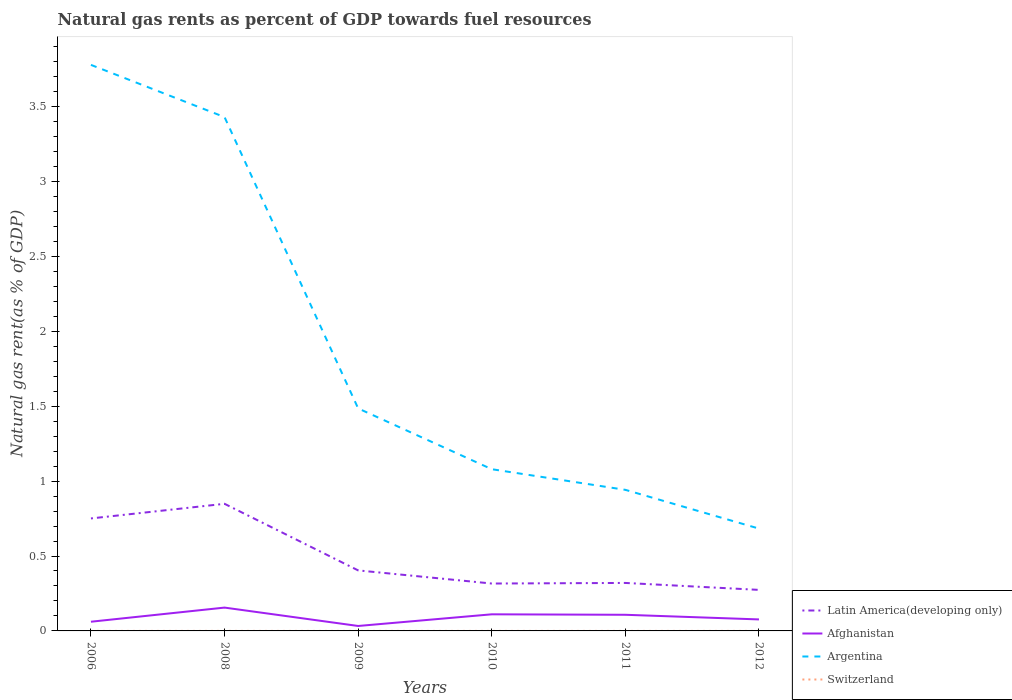Is the number of lines equal to the number of legend labels?
Keep it short and to the point. Yes. Across all years, what is the maximum natural gas rent in Afghanistan?
Provide a succinct answer. 0.03. What is the total natural gas rent in Switzerland in the graph?
Provide a succinct answer. 4.713673682386699e-5. What is the difference between the highest and the second highest natural gas rent in Argentina?
Your answer should be very brief. 3.09. What is the difference between the highest and the lowest natural gas rent in Latin America(developing only)?
Provide a short and direct response. 2. How many lines are there?
Offer a very short reply. 4. How many years are there in the graph?
Your answer should be compact. 6. Where does the legend appear in the graph?
Your response must be concise. Bottom right. What is the title of the graph?
Your answer should be very brief. Natural gas rents as percent of GDP towards fuel resources. Does "Belize" appear as one of the legend labels in the graph?
Provide a short and direct response. No. What is the label or title of the X-axis?
Your response must be concise. Years. What is the label or title of the Y-axis?
Keep it short and to the point. Natural gas rent(as % of GDP). What is the Natural gas rent(as % of GDP) in Latin America(developing only) in 2006?
Offer a terse response. 0.75. What is the Natural gas rent(as % of GDP) of Afghanistan in 2006?
Ensure brevity in your answer.  0.06. What is the Natural gas rent(as % of GDP) in Argentina in 2006?
Give a very brief answer. 3.78. What is the Natural gas rent(as % of GDP) of Switzerland in 2006?
Keep it short and to the point. 4.940501122730999e-5. What is the Natural gas rent(as % of GDP) in Latin America(developing only) in 2008?
Your answer should be compact. 0.85. What is the Natural gas rent(as % of GDP) of Afghanistan in 2008?
Keep it short and to the point. 0.16. What is the Natural gas rent(as % of GDP) of Argentina in 2008?
Your response must be concise. 3.43. What is the Natural gas rent(as % of GDP) in Switzerland in 2008?
Offer a very short reply. 0. What is the Natural gas rent(as % of GDP) of Latin America(developing only) in 2009?
Give a very brief answer. 0.4. What is the Natural gas rent(as % of GDP) of Afghanistan in 2009?
Keep it short and to the point. 0.03. What is the Natural gas rent(as % of GDP) of Argentina in 2009?
Make the answer very short. 1.48. What is the Natural gas rent(as % of GDP) in Switzerland in 2009?
Provide a short and direct response. 9.64984358457631e-5. What is the Natural gas rent(as % of GDP) in Latin America(developing only) in 2010?
Offer a terse response. 0.32. What is the Natural gas rent(as % of GDP) of Afghanistan in 2010?
Your answer should be compact. 0.11. What is the Natural gas rent(as % of GDP) in Argentina in 2010?
Give a very brief answer. 1.08. What is the Natural gas rent(as % of GDP) of Switzerland in 2010?
Provide a short and direct response. 0. What is the Natural gas rent(as % of GDP) of Latin America(developing only) in 2011?
Your answer should be very brief. 0.32. What is the Natural gas rent(as % of GDP) of Afghanistan in 2011?
Offer a very short reply. 0.11. What is the Natural gas rent(as % of GDP) in Argentina in 2011?
Provide a short and direct response. 0.94. What is the Natural gas rent(as % of GDP) of Switzerland in 2011?
Your answer should be very brief. 0. What is the Natural gas rent(as % of GDP) in Latin America(developing only) in 2012?
Give a very brief answer. 0.27. What is the Natural gas rent(as % of GDP) of Afghanistan in 2012?
Your answer should be very brief. 0.08. What is the Natural gas rent(as % of GDP) of Argentina in 2012?
Your answer should be very brief. 0.68. What is the Natural gas rent(as % of GDP) in Switzerland in 2012?
Offer a very short reply. 0. Across all years, what is the maximum Natural gas rent(as % of GDP) of Latin America(developing only)?
Offer a terse response. 0.85. Across all years, what is the maximum Natural gas rent(as % of GDP) of Afghanistan?
Make the answer very short. 0.16. Across all years, what is the maximum Natural gas rent(as % of GDP) of Argentina?
Your response must be concise. 3.78. Across all years, what is the maximum Natural gas rent(as % of GDP) in Switzerland?
Provide a short and direct response. 0. Across all years, what is the minimum Natural gas rent(as % of GDP) in Latin America(developing only)?
Ensure brevity in your answer.  0.27. Across all years, what is the minimum Natural gas rent(as % of GDP) in Afghanistan?
Your response must be concise. 0.03. Across all years, what is the minimum Natural gas rent(as % of GDP) of Argentina?
Provide a short and direct response. 0.68. Across all years, what is the minimum Natural gas rent(as % of GDP) in Switzerland?
Your response must be concise. 4.940501122730999e-5. What is the total Natural gas rent(as % of GDP) in Latin America(developing only) in the graph?
Give a very brief answer. 2.91. What is the total Natural gas rent(as % of GDP) of Afghanistan in the graph?
Your answer should be very brief. 0.55. What is the total Natural gas rent(as % of GDP) in Argentina in the graph?
Your response must be concise. 11.4. What is the total Natural gas rent(as % of GDP) in Switzerland in the graph?
Provide a succinct answer. 0. What is the difference between the Natural gas rent(as % of GDP) in Latin America(developing only) in 2006 and that in 2008?
Provide a succinct answer. -0.1. What is the difference between the Natural gas rent(as % of GDP) in Afghanistan in 2006 and that in 2008?
Offer a terse response. -0.09. What is the difference between the Natural gas rent(as % of GDP) in Argentina in 2006 and that in 2008?
Give a very brief answer. 0.35. What is the difference between the Natural gas rent(as % of GDP) of Switzerland in 2006 and that in 2008?
Make the answer very short. -0. What is the difference between the Natural gas rent(as % of GDP) in Latin America(developing only) in 2006 and that in 2009?
Your answer should be compact. 0.35. What is the difference between the Natural gas rent(as % of GDP) in Afghanistan in 2006 and that in 2009?
Your answer should be compact. 0.03. What is the difference between the Natural gas rent(as % of GDP) in Argentina in 2006 and that in 2009?
Offer a terse response. 2.29. What is the difference between the Natural gas rent(as % of GDP) of Latin America(developing only) in 2006 and that in 2010?
Provide a short and direct response. 0.43. What is the difference between the Natural gas rent(as % of GDP) of Afghanistan in 2006 and that in 2010?
Your response must be concise. -0.05. What is the difference between the Natural gas rent(as % of GDP) in Argentina in 2006 and that in 2010?
Keep it short and to the point. 2.7. What is the difference between the Natural gas rent(as % of GDP) of Switzerland in 2006 and that in 2010?
Make the answer very short. -0. What is the difference between the Natural gas rent(as % of GDP) of Latin America(developing only) in 2006 and that in 2011?
Your answer should be compact. 0.43. What is the difference between the Natural gas rent(as % of GDP) in Afghanistan in 2006 and that in 2011?
Offer a very short reply. -0.05. What is the difference between the Natural gas rent(as % of GDP) of Argentina in 2006 and that in 2011?
Offer a very short reply. 2.84. What is the difference between the Natural gas rent(as % of GDP) of Switzerland in 2006 and that in 2011?
Provide a short and direct response. -0. What is the difference between the Natural gas rent(as % of GDP) in Latin America(developing only) in 2006 and that in 2012?
Provide a short and direct response. 0.48. What is the difference between the Natural gas rent(as % of GDP) of Afghanistan in 2006 and that in 2012?
Give a very brief answer. -0.02. What is the difference between the Natural gas rent(as % of GDP) of Argentina in 2006 and that in 2012?
Your answer should be very brief. 3.09. What is the difference between the Natural gas rent(as % of GDP) in Switzerland in 2006 and that in 2012?
Your answer should be compact. -0. What is the difference between the Natural gas rent(as % of GDP) of Latin America(developing only) in 2008 and that in 2009?
Your response must be concise. 0.44. What is the difference between the Natural gas rent(as % of GDP) in Afghanistan in 2008 and that in 2009?
Offer a terse response. 0.12. What is the difference between the Natural gas rent(as % of GDP) in Argentina in 2008 and that in 2009?
Make the answer very short. 1.94. What is the difference between the Natural gas rent(as % of GDP) of Latin America(developing only) in 2008 and that in 2010?
Ensure brevity in your answer.  0.53. What is the difference between the Natural gas rent(as % of GDP) in Afghanistan in 2008 and that in 2010?
Provide a succinct answer. 0.04. What is the difference between the Natural gas rent(as % of GDP) in Argentina in 2008 and that in 2010?
Your answer should be compact. 2.35. What is the difference between the Natural gas rent(as % of GDP) of Latin America(developing only) in 2008 and that in 2011?
Provide a short and direct response. 0.53. What is the difference between the Natural gas rent(as % of GDP) of Afghanistan in 2008 and that in 2011?
Provide a short and direct response. 0.05. What is the difference between the Natural gas rent(as % of GDP) of Argentina in 2008 and that in 2011?
Keep it short and to the point. 2.49. What is the difference between the Natural gas rent(as % of GDP) of Switzerland in 2008 and that in 2011?
Your answer should be very brief. 0. What is the difference between the Natural gas rent(as % of GDP) in Latin America(developing only) in 2008 and that in 2012?
Keep it short and to the point. 0.57. What is the difference between the Natural gas rent(as % of GDP) of Afghanistan in 2008 and that in 2012?
Your response must be concise. 0.08. What is the difference between the Natural gas rent(as % of GDP) in Argentina in 2008 and that in 2012?
Keep it short and to the point. 2.75. What is the difference between the Natural gas rent(as % of GDP) of Latin America(developing only) in 2009 and that in 2010?
Your answer should be very brief. 0.09. What is the difference between the Natural gas rent(as % of GDP) in Afghanistan in 2009 and that in 2010?
Your response must be concise. -0.08. What is the difference between the Natural gas rent(as % of GDP) in Argentina in 2009 and that in 2010?
Keep it short and to the point. 0.41. What is the difference between the Natural gas rent(as % of GDP) in Latin America(developing only) in 2009 and that in 2011?
Your answer should be very brief. 0.08. What is the difference between the Natural gas rent(as % of GDP) in Afghanistan in 2009 and that in 2011?
Your answer should be compact. -0.07. What is the difference between the Natural gas rent(as % of GDP) of Argentina in 2009 and that in 2011?
Your answer should be compact. 0.54. What is the difference between the Natural gas rent(as % of GDP) in Switzerland in 2009 and that in 2011?
Ensure brevity in your answer.  -0. What is the difference between the Natural gas rent(as % of GDP) of Latin America(developing only) in 2009 and that in 2012?
Keep it short and to the point. 0.13. What is the difference between the Natural gas rent(as % of GDP) in Afghanistan in 2009 and that in 2012?
Provide a succinct answer. -0.04. What is the difference between the Natural gas rent(as % of GDP) of Argentina in 2009 and that in 2012?
Ensure brevity in your answer.  0.8. What is the difference between the Natural gas rent(as % of GDP) of Switzerland in 2009 and that in 2012?
Offer a terse response. -0. What is the difference between the Natural gas rent(as % of GDP) in Latin America(developing only) in 2010 and that in 2011?
Make the answer very short. -0. What is the difference between the Natural gas rent(as % of GDP) of Afghanistan in 2010 and that in 2011?
Your response must be concise. 0. What is the difference between the Natural gas rent(as % of GDP) in Argentina in 2010 and that in 2011?
Offer a terse response. 0.14. What is the difference between the Natural gas rent(as % of GDP) of Latin America(developing only) in 2010 and that in 2012?
Your answer should be compact. 0.04. What is the difference between the Natural gas rent(as % of GDP) of Afghanistan in 2010 and that in 2012?
Offer a very short reply. 0.03. What is the difference between the Natural gas rent(as % of GDP) of Argentina in 2010 and that in 2012?
Provide a short and direct response. 0.4. What is the difference between the Natural gas rent(as % of GDP) in Latin America(developing only) in 2011 and that in 2012?
Offer a very short reply. 0.05. What is the difference between the Natural gas rent(as % of GDP) in Afghanistan in 2011 and that in 2012?
Give a very brief answer. 0.03. What is the difference between the Natural gas rent(as % of GDP) in Argentina in 2011 and that in 2012?
Provide a short and direct response. 0.26. What is the difference between the Natural gas rent(as % of GDP) of Latin America(developing only) in 2006 and the Natural gas rent(as % of GDP) of Afghanistan in 2008?
Ensure brevity in your answer.  0.59. What is the difference between the Natural gas rent(as % of GDP) in Latin America(developing only) in 2006 and the Natural gas rent(as % of GDP) in Argentina in 2008?
Offer a very short reply. -2.68. What is the difference between the Natural gas rent(as % of GDP) of Latin America(developing only) in 2006 and the Natural gas rent(as % of GDP) of Switzerland in 2008?
Give a very brief answer. 0.75. What is the difference between the Natural gas rent(as % of GDP) of Afghanistan in 2006 and the Natural gas rent(as % of GDP) of Argentina in 2008?
Ensure brevity in your answer.  -3.37. What is the difference between the Natural gas rent(as % of GDP) in Afghanistan in 2006 and the Natural gas rent(as % of GDP) in Switzerland in 2008?
Your answer should be compact. 0.06. What is the difference between the Natural gas rent(as % of GDP) in Argentina in 2006 and the Natural gas rent(as % of GDP) in Switzerland in 2008?
Offer a very short reply. 3.78. What is the difference between the Natural gas rent(as % of GDP) of Latin America(developing only) in 2006 and the Natural gas rent(as % of GDP) of Afghanistan in 2009?
Make the answer very short. 0.72. What is the difference between the Natural gas rent(as % of GDP) of Latin America(developing only) in 2006 and the Natural gas rent(as % of GDP) of Argentina in 2009?
Make the answer very short. -0.73. What is the difference between the Natural gas rent(as % of GDP) in Latin America(developing only) in 2006 and the Natural gas rent(as % of GDP) in Switzerland in 2009?
Provide a short and direct response. 0.75. What is the difference between the Natural gas rent(as % of GDP) of Afghanistan in 2006 and the Natural gas rent(as % of GDP) of Argentina in 2009?
Your answer should be compact. -1.42. What is the difference between the Natural gas rent(as % of GDP) of Afghanistan in 2006 and the Natural gas rent(as % of GDP) of Switzerland in 2009?
Your answer should be very brief. 0.06. What is the difference between the Natural gas rent(as % of GDP) in Argentina in 2006 and the Natural gas rent(as % of GDP) in Switzerland in 2009?
Your answer should be very brief. 3.78. What is the difference between the Natural gas rent(as % of GDP) in Latin America(developing only) in 2006 and the Natural gas rent(as % of GDP) in Afghanistan in 2010?
Provide a short and direct response. 0.64. What is the difference between the Natural gas rent(as % of GDP) of Latin America(developing only) in 2006 and the Natural gas rent(as % of GDP) of Argentina in 2010?
Provide a short and direct response. -0.33. What is the difference between the Natural gas rent(as % of GDP) in Latin America(developing only) in 2006 and the Natural gas rent(as % of GDP) in Switzerland in 2010?
Provide a succinct answer. 0.75. What is the difference between the Natural gas rent(as % of GDP) of Afghanistan in 2006 and the Natural gas rent(as % of GDP) of Argentina in 2010?
Keep it short and to the point. -1.02. What is the difference between the Natural gas rent(as % of GDP) of Afghanistan in 2006 and the Natural gas rent(as % of GDP) of Switzerland in 2010?
Offer a very short reply. 0.06. What is the difference between the Natural gas rent(as % of GDP) of Argentina in 2006 and the Natural gas rent(as % of GDP) of Switzerland in 2010?
Provide a short and direct response. 3.78. What is the difference between the Natural gas rent(as % of GDP) of Latin America(developing only) in 2006 and the Natural gas rent(as % of GDP) of Afghanistan in 2011?
Make the answer very short. 0.64. What is the difference between the Natural gas rent(as % of GDP) in Latin America(developing only) in 2006 and the Natural gas rent(as % of GDP) in Argentina in 2011?
Your answer should be very brief. -0.19. What is the difference between the Natural gas rent(as % of GDP) of Latin America(developing only) in 2006 and the Natural gas rent(as % of GDP) of Switzerland in 2011?
Offer a very short reply. 0.75. What is the difference between the Natural gas rent(as % of GDP) in Afghanistan in 2006 and the Natural gas rent(as % of GDP) in Argentina in 2011?
Keep it short and to the point. -0.88. What is the difference between the Natural gas rent(as % of GDP) of Afghanistan in 2006 and the Natural gas rent(as % of GDP) of Switzerland in 2011?
Give a very brief answer. 0.06. What is the difference between the Natural gas rent(as % of GDP) in Argentina in 2006 and the Natural gas rent(as % of GDP) in Switzerland in 2011?
Keep it short and to the point. 3.78. What is the difference between the Natural gas rent(as % of GDP) of Latin America(developing only) in 2006 and the Natural gas rent(as % of GDP) of Afghanistan in 2012?
Your answer should be compact. 0.67. What is the difference between the Natural gas rent(as % of GDP) of Latin America(developing only) in 2006 and the Natural gas rent(as % of GDP) of Argentina in 2012?
Keep it short and to the point. 0.07. What is the difference between the Natural gas rent(as % of GDP) of Latin America(developing only) in 2006 and the Natural gas rent(as % of GDP) of Switzerland in 2012?
Provide a short and direct response. 0.75. What is the difference between the Natural gas rent(as % of GDP) in Afghanistan in 2006 and the Natural gas rent(as % of GDP) in Argentina in 2012?
Offer a very short reply. -0.62. What is the difference between the Natural gas rent(as % of GDP) in Afghanistan in 2006 and the Natural gas rent(as % of GDP) in Switzerland in 2012?
Your response must be concise. 0.06. What is the difference between the Natural gas rent(as % of GDP) of Argentina in 2006 and the Natural gas rent(as % of GDP) of Switzerland in 2012?
Offer a terse response. 3.78. What is the difference between the Natural gas rent(as % of GDP) of Latin America(developing only) in 2008 and the Natural gas rent(as % of GDP) of Afghanistan in 2009?
Offer a terse response. 0.82. What is the difference between the Natural gas rent(as % of GDP) in Latin America(developing only) in 2008 and the Natural gas rent(as % of GDP) in Argentina in 2009?
Give a very brief answer. -0.64. What is the difference between the Natural gas rent(as % of GDP) of Latin America(developing only) in 2008 and the Natural gas rent(as % of GDP) of Switzerland in 2009?
Your response must be concise. 0.85. What is the difference between the Natural gas rent(as % of GDP) of Afghanistan in 2008 and the Natural gas rent(as % of GDP) of Argentina in 2009?
Provide a short and direct response. -1.33. What is the difference between the Natural gas rent(as % of GDP) of Afghanistan in 2008 and the Natural gas rent(as % of GDP) of Switzerland in 2009?
Offer a terse response. 0.16. What is the difference between the Natural gas rent(as % of GDP) in Argentina in 2008 and the Natural gas rent(as % of GDP) in Switzerland in 2009?
Keep it short and to the point. 3.43. What is the difference between the Natural gas rent(as % of GDP) in Latin America(developing only) in 2008 and the Natural gas rent(as % of GDP) in Afghanistan in 2010?
Provide a succinct answer. 0.74. What is the difference between the Natural gas rent(as % of GDP) in Latin America(developing only) in 2008 and the Natural gas rent(as % of GDP) in Argentina in 2010?
Provide a succinct answer. -0.23. What is the difference between the Natural gas rent(as % of GDP) of Latin America(developing only) in 2008 and the Natural gas rent(as % of GDP) of Switzerland in 2010?
Offer a terse response. 0.85. What is the difference between the Natural gas rent(as % of GDP) of Afghanistan in 2008 and the Natural gas rent(as % of GDP) of Argentina in 2010?
Your response must be concise. -0.92. What is the difference between the Natural gas rent(as % of GDP) in Afghanistan in 2008 and the Natural gas rent(as % of GDP) in Switzerland in 2010?
Your answer should be very brief. 0.16. What is the difference between the Natural gas rent(as % of GDP) in Argentina in 2008 and the Natural gas rent(as % of GDP) in Switzerland in 2010?
Your answer should be compact. 3.43. What is the difference between the Natural gas rent(as % of GDP) of Latin America(developing only) in 2008 and the Natural gas rent(as % of GDP) of Afghanistan in 2011?
Your answer should be very brief. 0.74. What is the difference between the Natural gas rent(as % of GDP) in Latin America(developing only) in 2008 and the Natural gas rent(as % of GDP) in Argentina in 2011?
Your answer should be very brief. -0.09. What is the difference between the Natural gas rent(as % of GDP) in Latin America(developing only) in 2008 and the Natural gas rent(as % of GDP) in Switzerland in 2011?
Ensure brevity in your answer.  0.85. What is the difference between the Natural gas rent(as % of GDP) in Afghanistan in 2008 and the Natural gas rent(as % of GDP) in Argentina in 2011?
Keep it short and to the point. -0.79. What is the difference between the Natural gas rent(as % of GDP) of Afghanistan in 2008 and the Natural gas rent(as % of GDP) of Switzerland in 2011?
Provide a succinct answer. 0.16. What is the difference between the Natural gas rent(as % of GDP) in Argentina in 2008 and the Natural gas rent(as % of GDP) in Switzerland in 2011?
Your response must be concise. 3.43. What is the difference between the Natural gas rent(as % of GDP) of Latin America(developing only) in 2008 and the Natural gas rent(as % of GDP) of Afghanistan in 2012?
Your answer should be very brief. 0.77. What is the difference between the Natural gas rent(as % of GDP) in Latin America(developing only) in 2008 and the Natural gas rent(as % of GDP) in Argentina in 2012?
Offer a terse response. 0.17. What is the difference between the Natural gas rent(as % of GDP) of Latin America(developing only) in 2008 and the Natural gas rent(as % of GDP) of Switzerland in 2012?
Your answer should be compact. 0.85. What is the difference between the Natural gas rent(as % of GDP) of Afghanistan in 2008 and the Natural gas rent(as % of GDP) of Argentina in 2012?
Ensure brevity in your answer.  -0.53. What is the difference between the Natural gas rent(as % of GDP) in Afghanistan in 2008 and the Natural gas rent(as % of GDP) in Switzerland in 2012?
Make the answer very short. 0.16. What is the difference between the Natural gas rent(as % of GDP) in Argentina in 2008 and the Natural gas rent(as % of GDP) in Switzerland in 2012?
Give a very brief answer. 3.43. What is the difference between the Natural gas rent(as % of GDP) of Latin America(developing only) in 2009 and the Natural gas rent(as % of GDP) of Afghanistan in 2010?
Provide a succinct answer. 0.29. What is the difference between the Natural gas rent(as % of GDP) in Latin America(developing only) in 2009 and the Natural gas rent(as % of GDP) in Argentina in 2010?
Your answer should be very brief. -0.68. What is the difference between the Natural gas rent(as % of GDP) in Latin America(developing only) in 2009 and the Natural gas rent(as % of GDP) in Switzerland in 2010?
Keep it short and to the point. 0.4. What is the difference between the Natural gas rent(as % of GDP) in Afghanistan in 2009 and the Natural gas rent(as % of GDP) in Argentina in 2010?
Make the answer very short. -1.05. What is the difference between the Natural gas rent(as % of GDP) in Afghanistan in 2009 and the Natural gas rent(as % of GDP) in Switzerland in 2010?
Give a very brief answer. 0.03. What is the difference between the Natural gas rent(as % of GDP) in Argentina in 2009 and the Natural gas rent(as % of GDP) in Switzerland in 2010?
Your answer should be very brief. 1.48. What is the difference between the Natural gas rent(as % of GDP) in Latin America(developing only) in 2009 and the Natural gas rent(as % of GDP) in Afghanistan in 2011?
Your answer should be very brief. 0.3. What is the difference between the Natural gas rent(as % of GDP) in Latin America(developing only) in 2009 and the Natural gas rent(as % of GDP) in Argentina in 2011?
Provide a short and direct response. -0.54. What is the difference between the Natural gas rent(as % of GDP) of Latin America(developing only) in 2009 and the Natural gas rent(as % of GDP) of Switzerland in 2011?
Your answer should be compact. 0.4. What is the difference between the Natural gas rent(as % of GDP) in Afghanistan in 2009 and the Natural gas rent(as % of GDP) in Argentina in 2011?
Provide a short and direct response. -0.91. What is the difference between the Natural gas rent(as % of GDP) of Afghanistan in 2009 and the Natural gas rent(as % of GDP) of Switzerland in 2011?
Your response must be concise. 0.03. What is the difference between the Natural gas rent(as % of GDP) in Argentina in 2009 and the Natural gas rent(as % of GDP) in Switzerland in 2011?
Offer a very short reply. 1.48. What is the difference between the Natural gas rent(as % of GDP) in Latin America(developing only) in 2009 and the Natural gas rent(as % of GDP) in Afghanistan in 2012?
Provide a short and direct response. 0.33. What is the difference between the Natural gas rent(as % of GDP) in Latin America(developing only) in 2009 and the Natural gas rent(as % of GDP) in Argentina in 2012?
Provide a succinct answer. -0.28. What is the difference between the Natural gas rent(as % of GDP) of Latin America(developing only) in 2009 and the Natural gas rent(as % of GDP) of Switzerland in 2012?
Provide a succinct answer. 0.4. What is the difference between the Natural gas rent(as % of GDP) of Afghanistan in 2009 and the Natural gas rent(as % of GDP) of Argentina in 2012?
Your response must be concise. -0.65. What is the difference between the Natural gas rent(as % of GDP) in Afghanistan in 2009 and the Natural gas rent(as % of GDP) in Switzerland in 2012?
Your answer should be compact. 0.03. What is the difference between the Natural gas rent(as % of GDP) in Argentina in 2009 and the Natural gas rent(as % of GDP) in Switzerland in 2012?
Offer a terse response. 1.48. What is the difference between the Natural gas rent(as % of GDP) of Latin America(developing only) in 2010 and the Natural gas rent(as % of GDP) of Afghanistan in 2011?
Provide a succinct answer. 0.21. What is the difference between the Natural gas rent(as % of GDP) in Latin America(developing only) in 2010 and the Natural gas rent(as % of GDP) in Argentina in 2011?
Your response must be concise. -0.63. What is the difference between the Natural gas rent(as % of GDP) in Latin America(developing only) in 2010 and the Natural gas rent(as % of GDP) in Switzerland in 2011?
Give a very brief answer. 0.32. What is the difference between the Natural gas rent(as % of GDP) in Afghanistan in 2010 and the Natural gas rent(as % of GDP) in Argentina in 2011?
Provide a short and direct response. -0.83. What is the difference between the Natural gas rent(as % of GDP) in Afghanistan in 2010 and the Natural gas rent(as % of GDP) in Switzerland in 2011?
Your response must be concise. 0.11. What is the difference between the Natural gas rent(as % of GDP) of Argentina in 2010 and the Natural gas rent(as % of GDP) of Switzerland in 2011?
Give a very brief answer. 1.08. What is the difference between the Natural gas rent(as % of GDP) in Latin America(developing only) in 2010 and the Natural gas rent(as % of GDP) in Afghanistan in 2012?
Your answer should be compact. 0.24. What is the difference between the Natural gas rent(as % of GDP) in Latin America(developing only) in 2010 and the Natural gas rent(as % of GDP) in Argentina in 2012?
Keep it short and to the point. -0.37. What is the difference between the Natural gas rent(as % of GDP) in Latin America(developing only) in 2010 and the Natural gas rent(as % of GDP) in Switzerland in 2012?
Provide a succinct answer. 0.32. What is the difference between the Natural gas rent(as % of GDP) of Afghanistan in 2010 and the Natural gas rent(as % of GDP) of Argentina in 2012?
Offer a very short reply. -0.57. What is the difference between the Natural gas rent(as % of GDP) of Afghanistan in 2010 and the Natural gas rent(as % of GDP) of Switzerland in 2012?
Ensure brevity in your answer.  0.11. What is the difference between the Natural gas rent(as % of GDP) in Argentina in 2010 and the Natural gas rent(as % of GDP) in Switzerland in 2012?
Your answer should be very brief. 1.08. What is the difference between the Natural gas rent(as % of GDP) of Latin America(developing only) in 2011 and the Natural gas rent(as % of GDP) of Afghanistan in 2012?
Your answer should be compact. 0.24. What is the difference between the Natural gas rent(as % of GDP) of Latin America(developing only) in 2011 and the Natural gas rent(as % of GDP) of Argentina in 2012?
Provide a short and direct response. -0.36. What is the difference between the Natural gas rent(as % of GDP) of Latin America(developing only) in 2011 and the Natural gas rent(as % of GDP) of Switzerland in 2012?
Provide a short and direct response. 0.32. What is the difference between the Natural gas rent(as % of GDP) in Afghanistan in 2011 and the Natural gas rent(as % of GDP) in Argentina in 2012?
Give a very brief answer. -0.58. What is the difference between the Natural gas rent(as % of GDP) in Afghanistan in 2011 and the Natural gas rent(as % of GDP) in Switzerland in 2012?
Keep it short and to the point. 0.11. What is the difference between the Natural gas rent(as % of GDP) of Argentina in 2011 and the Natural gas rent(as % of GDP) of Switzerland in 2012?
Your answer should be very brief. 0.94. What is the average Natural gas rent(as % of GDP) of Latin America(developing only) per year?
Your answer should be compact. 0.49. What is the average Natural gas rent(as % of GDP) of Afghanistan per year?
Give a very brief answer. 0.09. What is the average Natural gas rent(as % of GDP) of Argentina per year?
Keep it short and to the point. 1.9. In the year 2006, what is the difference between the Natural gas rent(as % of GDP) in Latin America(developing only) and Natural gas rent(as % of GDP) in Afghanistan?
Your answer should be compact. 0.69. In the year 2006, what is the difference between the Natural gas rent(as % of GDP) in Latin America(developing only) and Natural gas rent(as % of GDP) in Argentina?
Ensure brevity in your answer.  -3.03. In the year 2006, what is the difference between the Natural gas rent(as % of GDP) of Latin America(developing only) and Natural gas rent(as % of GDP) of Switzerland?
Offer a very short reply. 0.75. In the year 2006, what is the difference between the Natural gas rent(as % of GDP) in Afghanistan and Natural gas rent(as % of GDP) in Argentina?
Your response must be concise. -3.72. In the year 2006, what is the difference between the Natural gas rent(as % of GDP) in Afghanistan and Natural gas rent(as % of GDP) in Switzerland?
Offer a terse response. 0.06. In the year 2006, what is the difference between the Natural gas rent(as % of GDP) in Argentina and Natural gas rent(as % of GDP) in Switzerland?
Offer a terse response. 3.78. In the year 2008, what is the difference between the Natural gas rent(as % of GDP) in Latin America(developing only) and Natural gas rent(as % of GDP) in Afghanistan?
Provide a succinct answer. 0.69. In the year 2008, what is the difference between the Natural gas rent(as % of GDP) in Latin America(developing only) and Natural gas rent(as % of GDP) in Argentina?
Provide a succinct answer. -2.58. In the year 2008, what is the difference between the Natural gas rent(as % of GDP) in Latin America(developing only) and Natural gas rent(as % of GDP) in Switzerland?
Your response must be concise. 0.85. In the year 2008, what is the difference between the Natural gas rent(as % of GDP) in Afghanistan and Natural gas rent(as % of GDP) in Argentina?
Offer a terse response. -3.27. In the year 2008, what is the difference between the Natural gas rent(as % of GDP) of Afghanistan and Natural gas rent(as % of GDP) of Switzerland?
Offer a very short reply. 0.16. In the year 2008, what is the difference between the Natural gas rent(as % of GDP) of Argentina and Natural gas rent(as % of GDP) of Switzerland?
Give a very brief answer. 3.43. In the year 2009, what is the difference between the Natural gas rent(as % of GDP) in Latin America(developing only) and Natural gas rent(as % of GDP) in Afghanistan?
Your answer should be very brief. 0.37. In the year 2009, what is the difference between the Natural gas rent(as % of GDP) in Latin America(developing only) and Natural gas rent(as % of GDP) in Argentina?
Provide a short and direct response. -1.08. In the year 2009, what is the difference between the Natural gas rent(as % of GDP) in Latin America(developing only) and Natural gas rent(as % of GDP) in Switzerland?
Your response must be concise. 0.4. In the year 2009, what is the difference between the Natural gas rent(as % of GDP) of Afghanistan and Natural gas rent(as % of GDP) of Argentina?
Ensure brevity in your answer.  -1.45. In the year 2009, what is the difference between the Natural gas rent(as % of GDP) in Afghanistan and Natural gas rent(as % of GDP) in Switzerland?
Offer a very short reply. 0.03. In the year 2009, what is the difference between the Natural gas rent(as % of GDP) in Argentina and Natural gas rent(as % of GDP) in Switzerland?
Keep it short and to the point. 1.48. In the year 2010, what is the difference between the Natural gas rent(as % of GDP) of Latin America(developing only) and Natural gas rent(as % of GDP) of Afghanistan?
Your answer should be compact. 0.21. In the year 2010, what is the difference between the Natural gas rent(as % of GDP) of Latin America(developing only) and Natural gas rent(as % of GDP) of Argentina?
Make the answer very short. -0.76. In the year 2010, what is the difference between the Natural gas rent(as % of GDP) in Latin America(developing only) and Natural gas rent(as % of GDP) in Switzerland?
Offer a terse response. 0.32. In the year 2010, what is the difference between the Natural gas rent(as % of GDP) of Afghanistan and Natural gas rent(as % of GDP) of Argentina?
Offer a terse response. -0.97. In the year 2010, what is the difference between the Natural gas rent(as % of GDP) in Afghanistan and Natural gas rent(as % of GDP) in Switzerland?
Your response must be concise. 0.11. In the year 2010, what is the difference between the Natural gas rent(as % of GDP) of Argentina and Natural gas rent(as % of GDP) of Switzerland?
Offer a terse response. 1.08. In the year 2011, what is the difference between the Natural gas rent(as % of GDP) in Latin America(developing only) and Natural gas rent(as % of GDP) in Afghanistan?
Your response must be concise. 0.21. In the year 2011, what is the difference between the Natural gas rent(as % of GDP) of Latin America(developing only) and Natural gas rent(as % of GDP) of Argentina?
Make the answer very short. -0.62. In the year 2011, what is the difference between the Natural gas rent(as % of GDP) in Latin America(developing only) and Natural gas rent(as % of GDP) in Switzerland?
Keep it short and to the point. 0.32. In the year 2011, what is the difference between the Natural gas rent(as % of GDP) of Afghanistan and Natural gas rent(as % of GDP) of Argentina?
Provide a short and direct response. -0.83. In the year 2011, what is the difference between the Natural gas rent(as % of GDP) of Afghanistan and Natural gas rent(as % of GDP) of Switzerland?
Offer a very short reply. 0.11. In the year 2011, what is the difference between the Natural gas rent(as % of GDP) in Argentina and Natural gas rent(as % of GDP) in Switzerland?
Make the answer very short. 0.94. In the year 2012, what is the difference between the Natural gas rent(as % of GDP) in Latin America(developing only) and Natural gas rent(as % of GDP) in Afghanistan?
Ensure brevity in your answer.  0.2. In the year 2012, what is the difference between the Natural gas rent(as % of GDP) in Latin America(developing only) and Natural gas rent(as % of GDP) in Argentina?
Provide a short and direct response. -0.41. In the year 2012, what is the difference between the Natural gas rent(as % of GDP) in Latin America(developing only) and Natural gas rent(as % of GDP) in Switzerland?
Ensure brevity in your answer.  0.27. In the year 2012, what is the difference between the Natural gas rent(as % of GDP) of Afghanistan and Natural gas rent(as % of GDP) of Argentina?
Give a very brief answer. -0.61. In the year 2012, what is the difference between the Natural gas rent(as % of GDP) of Afghanistan and Natural gas rent(as % of GDP) of Switzerland?
Your answer should be compact. 0.08. In the year 2012, what is the difference between the Natural gas rent(as % of GDP) in Argentina and Natural gas rent(as % of GDP) in Switzerland?
Your answer should be very brief. 0.68. What is the ratio of the Natural gas rent(as % of GDP) in Latin America(developing only) in 2006 to that in 2008?
Your answer should be very brief. 0.88. What is the ratio of the Natural gas rent(as % of GDP) in Afghanistan in 2006 to that in 2008?
Make the answer very short. 0.39. What is the ratio of the Natural gas rent(as % of GDP) in Argentina in 2006 to that in 2008?
Ensure brevity in your answer.  1.1. What is the ratio of the Natural gas rent(as % of GDP) in Switzerland in 2006 to that in 2008?
Your response must be concise. 0.29. What is the ratio of the Natural gas rent(as % of GDP) in Latin America(developing only) in 2006 to that in 2009?
Your answer should be very brief. 1.86. What is the ratio of the Natural gas rent(as % of GDP) of Afghanistan in 2006 to that in 2009?
Keep it short and to the point. 1.86. What is the ratio of the Natural gas rent(as % of GDP) in Argentina in 2006 to that in 2009?
Offer a very short reply. 2.54. What is the ratio of the Natural gas rent(as % of GDP) of Switzerland in 2006 to that in 2009?
Your answer should be compact. 0.51. What is the ratio of the Natural gas rent(as % of GDP) in Latin America(developing only) in 2006 to that in 2010?
Your response must be concise. 2.37. What is the ratio of the Natural gas rent(as % of GDP) of Afghanistan in 2006 to that in 2010?
Your response must be concise. 0.55. What is the ratio of the Natural gas rent(as % of GDP) in Argentina in 2006 to that in 2010?
Provide a succinct answer. 3.5. What is the ratio of the Natural gas rent(as % of GDP) in Switzerland in 2006 to that in 2010?
Your answer should be very brief. 0.41. What is the ratio of the Natural gas rent(as % of GDP) of Latin America(developing only) in 2006 to that in 2011?
Offer a terse response. 2.34. What is the ratio of the Natural gas rent(as % of GDP) in Afghanistan in 2006 to that in 2011?
Your response must be concise. 0.57. What is the ratio of the Natural gas rent(as % of GDP) of Argentina in 2006 to that in 2011?
Offer a very short reply. 4.01. What is the ratio of the Natural gas rent(as % of GDP) in Switzerland in 2006 to that in 2011?
Provide a short and direct response. 0.34. What is the ratio of the Natural gas rent(as % of GDP) in Latin America(developing only) in 2006 to that in 2012?
Give a very brief answer. 2.74. What is the ratio of the Natural gas rent(as % of GDP) of Afghanistan in 2006 to that in 2012?
Provide a succinct answer. 0.8. What is the ratio of the Natural gas rent(as % of GDP) of Argentina in 2006 to that in 2012?
Offer a terse response. 5.53. What is the ratio of the Natural gas rent(as % of GDP) of Switzerland in 2006 to that in 2012?
Provide a succinct answer. 0.36. What is the ratio of the Natural gas rent(as % of GDP) in Latin America(developing only) in 2008 to that in 2009?
Give a very brief answer. 2.1. What is the ratio of the Natural gas rent(as % of GDP) in Afghanistan in 2008 to that in 2009?
Offer a very short reply. 4.72. What is the ratio of the Natural gas rent(as % of GDP) in Argentina in 2008 to that in 2009?
Offer a terse response. 2.31. What is the ratio of the Natural gas rent(as % of GDP) of Switzerland in 2008 to that in 2009?
Provide a succinct answer. 1.75. What is the ratio of the Natural gas rent(as % of GDP) of Latin America(developing only) in 2008 to that in 2010?
Offer a terse response. 2.68. What is the ratio of the Natural gas rent(as % of GDP) in Afghanistan in 2008 to that in 2010?
Your response must be concise. 1.4. What is the ratio of the Natural gas rent(as % of GDP) in Argentina in 2008 to that in 2010?
Make the answer very short. 3.18. What is the ratio of the Natural gas rent(as % of GDP) of Switzerland in 2008 to that in 2010?
Offer a terse response. 1.39. What is the ratio of the Natural gas rent(as % of GDP) in Latin America(developing only) in 2008 to that in 2011?
Your answer should be compact. 2.65. What is the ratio of the Natural gas rent(as % of GDP) in Afghanistan in 2008 to that in 2011?
Keep it short and to the point. 1.45. What is the ratio of the Natural gas rent(as % of GDP) of Argentina in 2008 to that in 2011?
Your answer should be compact. 3.64. What is the ratio of the Natural gas rent(as % of GDP) of Switzerland in 2008 to that in 2011?
Provide a short and direct response. 1.15. What is the ratio of the Natural gas rent(as % of GDP) in Latin America(developing only) in 2008 to that in 2012?
Offer a terse response. 3.1. What is the ratio of the Natural gas rent(as % of GDP) in Afghanistan in 2008 to that in 2012?
Provide a succinct answer. 2.03. What is the ratio of the Natural gas rent(as % of GDP) in Argentina in 2008 to that in 2012?
Keep it short and to the point. 5.02. What is the ratio of the Natural gas rent(as % of GDP) of Switzerland in 2008 to that in 2012?
Ensure brevity in your answer.  1.24. What is the ratio of the Natural gas rent(as % of GDP) in Latin America(developing only) in 2009 to that in 2010?
Offer a terse response. 1.28. What is the ratio of the Natural gas rent(as % of GDP) in Afghanistan in 2009 to that in 2010?
Provide a succinct answer. 0.3. What is the ratio of the Natural gas rent(as % of GDP) of Argentina in 2009 to that in 2010?
Your response must be concise. 1.38. What is the ratio of the Natural gas rent(as % of GDP) of Switzerland in 2009 to that in 2010?
Make the answer very short. 0.79. What is the ratio of the Natural gas rent(as % of GDP) in Latin America(developing only) in 2009 to that in 2011?
Make the answer very short. 1.26. What is the ratio of the Natural gas rent(as % of GDP) of Afghanistan in 2009 to that in 2011?
Your answer should be compact. 0.31. What is the ratio of the Natural gas rent(as % of GDP) of Argentina in 2009 to that in 2011?
Offer a very short reply. 1.58. What is the ratio of the Natural gas rent(as % of GDP) of Switzerland in 2009 to that in 2011?
Your answer should be compact. 0.66. What is the ratio of the Natural gas rent(as % of GDP) in Latin America(developing only) in 2009 to that in 2012?
Ensure brevity in your answer.  1.47. What is the ratio of the Natural gas rent(as % of GDP) in Afghanistan in 2009 to that in 2012?
Your answer should be compact. 0.43. What is the ratio of the Natural gas rent(as % of GDP) of Argentina in 2009 to that in 2012?
Your answer should be compact. 2.17. What is the ratio of the Natural gas rent(as % of GDP) of Switzerland in 2009 to that in 2012?
Your answer should be very brief. 0.71. What is the ratio of the Natural gas rent(as % of GDP) in Latin America(developing only) in 2010 to that in 2011?
Your answer should be very brief. 0.99. What is the ratio of the Natural gas rent(as % of GDP) of Afghanistan in 2010 to that in 2011?
Ensure brevity in your answer.  1.03. What is the ratio of the Natural gas rent(as % of GDP) in Argentina in 2010 to that in 2011?
Provide a succinct answer. 1.15. What is the ratio of the Natural gas rent(as % of GDP) in Switzerland in 2010 to that in 2011?
Provide a succinct answer. 0.83. What is the ratio of the Natural gas rent(as % of GDP) of Latin America(developing only) in 2010 to that in 2012?
Offer a very short reply. 1.15. What is the ratio of the Natural gas rent(as % of GDP) of Afghanistan in 2010 to that in 2012?
Provide a succinct answer. 1.44. What is the ratio of the Natural gas rent(as % of GDP) of Argentina in 2010 to that in 2012?
Your response must be concise. 1.58. What is the ratio of the Natural gas rent(as % of GDP) in Switzerland in 2010 to that in 2012?
Offer a terse response. 0.89. What is the ratio of the Natural gas rent(as % of GDP) of Latin America(developing only) in 2011 to that in 2012?
Ensure brevity in your answer.  1.17. What is the ratio of the Natural gas rent(as % of GDP) of Afghanistan in 2011 to that in 2012?
Provide a succinct answer. 1.4. What is the ratio of the Natural gas rent(as % of GDP) in Argentina in 2011 to that in 2012?
Give a very brief answer. 1.38. What is the ratio of the Natural gas rent(as % of GDP) of Switzerland in 2011 to that in 2012?
Provide a short and direct response. 1.08. What is the difference between the highest and the second highest Natural gas rent(as % of GDP) in Latin America(developing only)?
Make the answer very short. 0.1. What is the difference between the highest and the second highest Natural gas rent(as % of GDP) in Afghanistan?
Provide a short and direct response. 0.04. What is the difference between the highest and the second highest Natural gas rent(as % of GDP) in Argentina?
Your answer should be very brief. 0.35. What is the difference between the highest and the lowest Natural gas rent(as % of GDP) in Latin America(developing only)?
Ensure brevity in your answer.  0.57. What is the difference between the highest and the lowest Natural gas rent(as % of GDP) in Afghanistan?
Make the answer very short. 0.12. What is the difference between the highest and the lowest Natural gas rent(as % of GDP) of Argentina?
Your response must be concise. 3.09. 